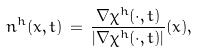Convert formula to latex. <formula><loc_0><loc_0><loc_500><loc_500>n ^ { h } ( x , t ) \, = \, \frac { \nabla \chi ^ { h } ( \cdot , t ) } { | \nabla \chi ^ { h } ( \cdot , t ) | } ( x ) ,</formula> 